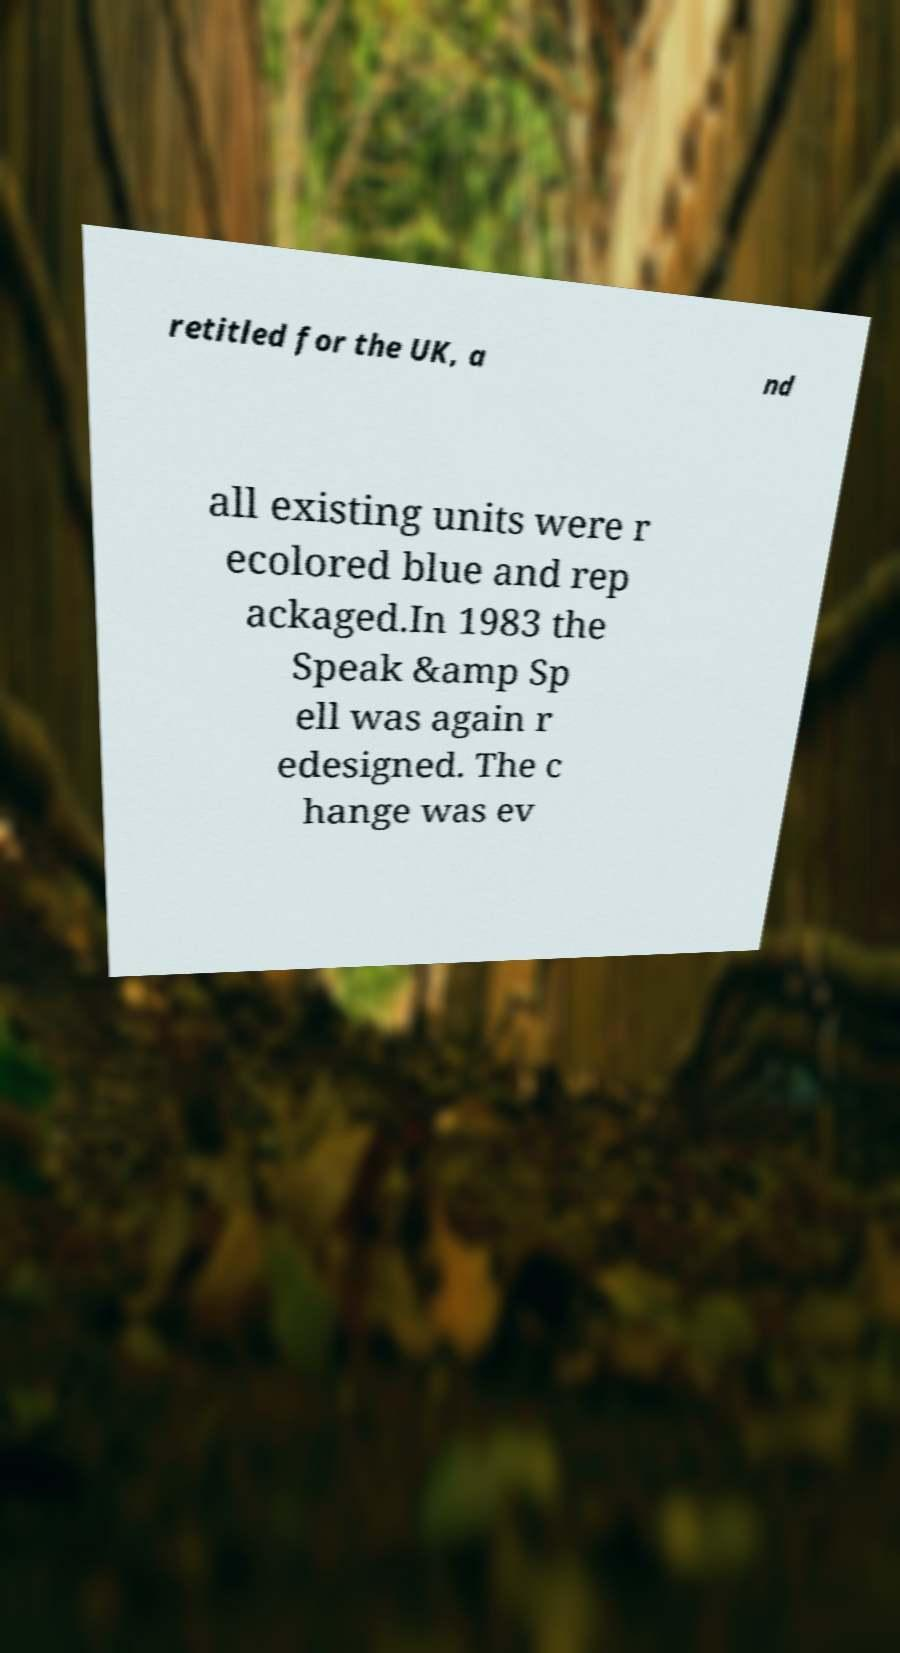For documentation purposes, I need the text within this image transcribed. Could you provide that? retitled for the UK, a nd all existing units were r ecolored blue and rep ackaged.In 1983 the Speak &amp Sp ell was again r edesigned. The c hange was ev 